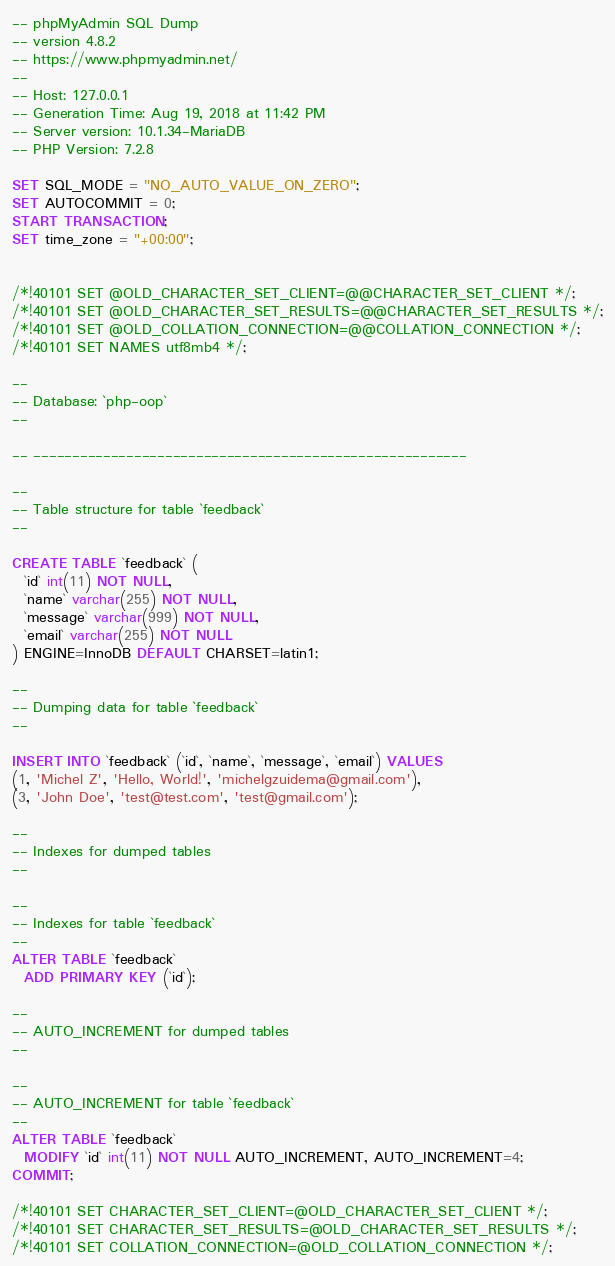Convert code to text. <code><loc_0><loc_0><loc_500><loc_500><_SQL_>-- phpMyAdmin SQL Dump
-- version 4.8.2
-- https://www.phpmyadmin.net/
--
-- Host: 127.0.0.1
-- Generation Time: Aug 19, 2018 at 11:42 PM
-- Server version: 10.1.34-MariaDB
-- PHP Version: 7.2.8

SET SQL_MODE = "NO_AUTO_VALUE_ON_ZERO";
SET AUTOCOMMIT = 0;
START TRANSACTION;
SET time_zone = "+00:00";


/*!40101 SET @OLD_CHARACTER_SET_CLIENT=@@CHARACTER_SET_CLIENT */;
/*!40101 SET @OLD_CHARACTER_SET_RESULTS=@@CHARACTER_SET_RESULTS */;
/*!40101 SET @OLD_COLLATION_CONNECTION=@@COLLATION_CONNECTION */;
/*!40101 SET NAMES utf8mb4 */;

--
-- Database: `php-oop`
--

-- --------------------------------------------------------

--
-- Table structure for table `feedback`
--

CREATE TABLE `feedback` (
  `id` int(11) NOT NULL,
  `name` varchar(255) NOT NULL,
  `message` varchar(999) NOT NULL,
  `email` varchar(255) NOT NULL
) ENGINE=InnoDB DEFAULT CHARSET=latin1;

--
-- Dumping data for table `feedback`
--

INSERT INTO `feedback` (`id`, `name`, `message`, `email`) VALUES
(1, 'Michel Z', 'Hello, World!', 'michelgzuidema@gmail.com'),
(3, 'John Doe', 'test@test.com', 'test@gmail.com');

--
-- Indexes for dumped tables
--

--
-- Indexes for table `feedback`
--
ALTER TABLE `feedback`
  ADD PRIMARY KEY (`id`);

--
-- AUTO_INCREMENT for dumped tables
--

--
-- AUTO_INCREMENT for table `feedback`
--
ALTER TABLE `feedback`
  MODIFY `id` int(11) NOT NULL AUTO_INCREMENT, AUTO_INCREMENT=4;
COMMIT;

/*!40101 SET CHARACTER_SET_CLIENT=@OLD_CHARACTER_SET_CLIENT */;
/*!40101 SET CHARACTER_SET_RESULTS=@OLD_CHARACTER_SET_RESULTS */;
/*!40101 SET COLLATION_CONNECTION=@OLD_COLLATION_CONNECTION */;
</code> 